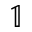Convert formula to latex. <formula><loc_0><loc_0><loc_500><loc_500>\mathbb { 1 }</formula> 